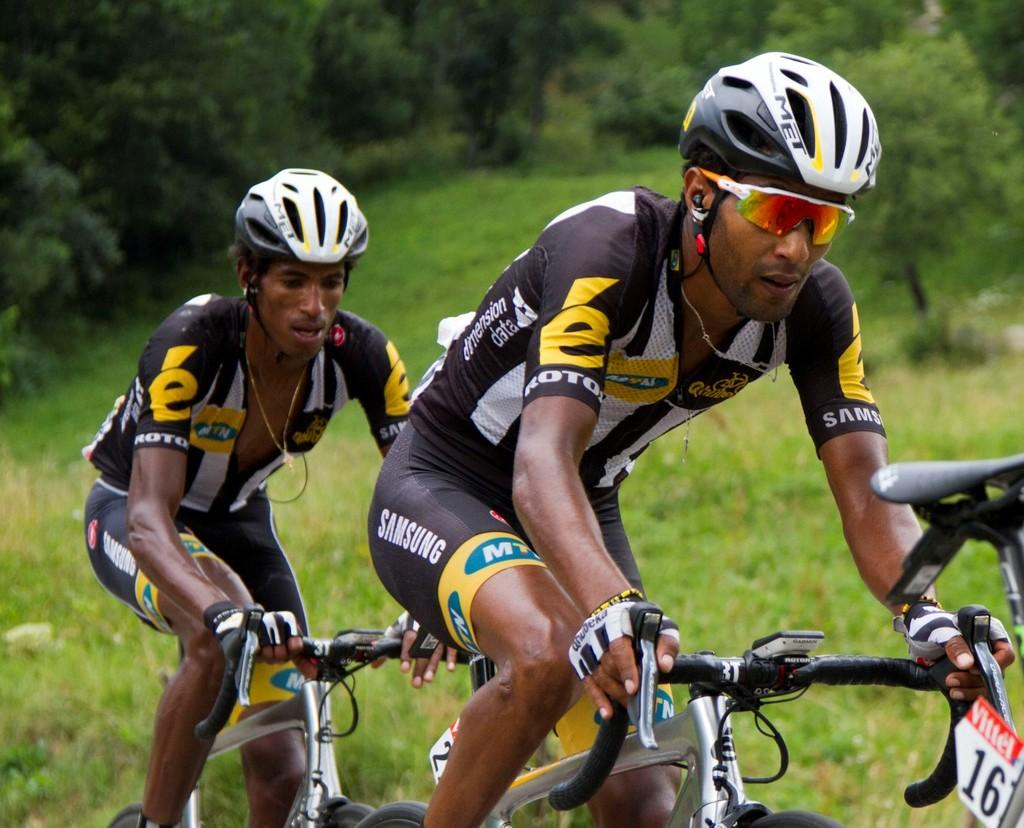How many people are in the image? There are two men in the image. What are the men doing in the image? The men are riding bicycles. What safety equipment are the men wearing? The men are wearing helmets and gloves. What type of terrain can be seen in the image? There is grass visible in the image. What is visible in the background of the image? There are trees in the background of the image. What type of light bulb is hanging from the dock in the image? There is no dock or light bulb present in the image. 